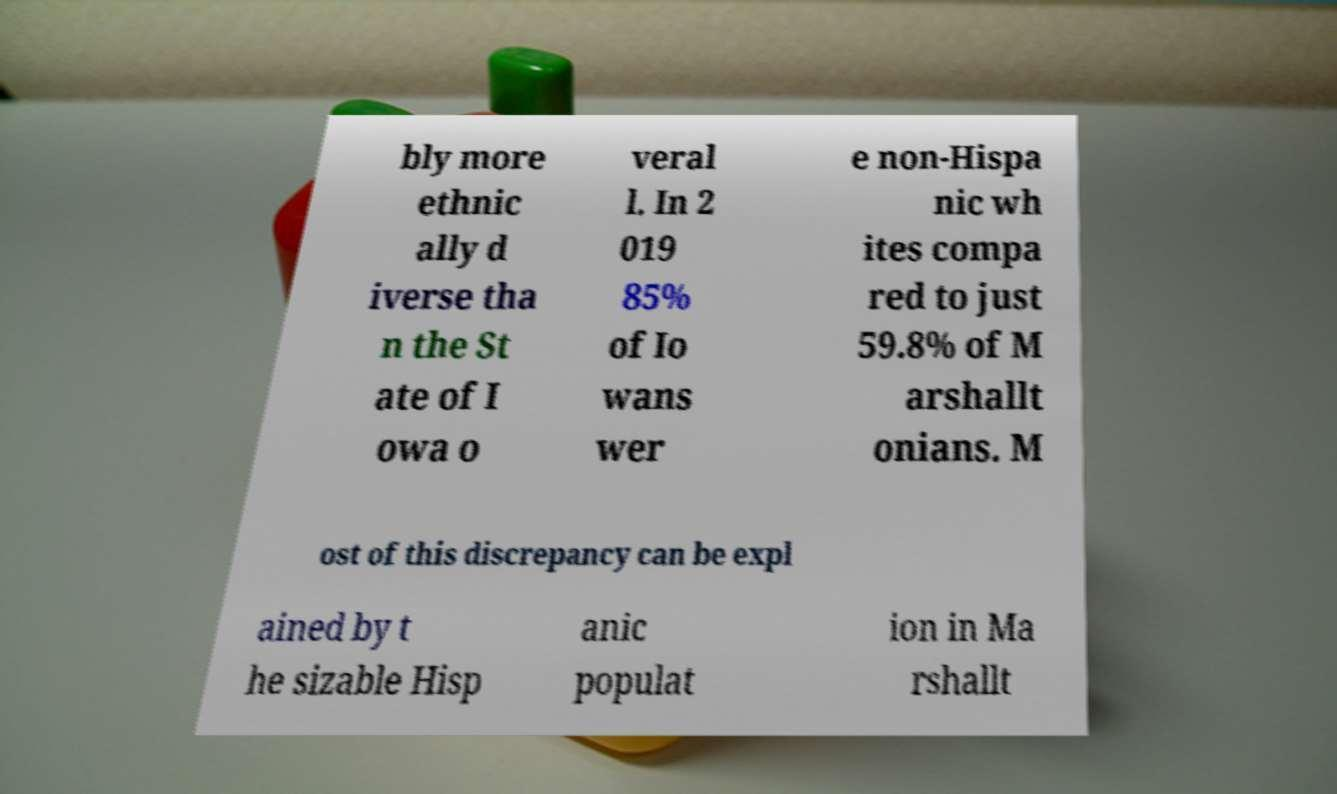Could you assist in decoding the text presented in this image and type it out clearly? bly more ethnic ally d iverse tha n the St ate of I owa o veral l. In 2 019 85% of Io wans wer e non-Hispa nic wh ites compa red to just 59.8% of M arshallt onians. M ost of this discrepancy can be expl ained by t he sizable Hisp anic populat ion in Ma rshallt 